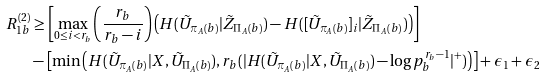<formula> <loc_0><loc_0><loc_500><loc_500>R _ { 1 b } ^ { ( 2 ) } & \geq \left [ \max _ { 0 \leq i < r _ { b } } \left ( \frac { r _ { b } } { r _ { b } - i } \right ) \left ( H ( \tilde { U } _ { \pi _ { A } ( b ) } | \tilde { Z } _ { \Pi _ { A } ( b ) } ) - H ( [ \tilde { U } _ { \pi _ { A } ( b ) } ] _ { i } | \tilde { Z } _ { \Pi _ { A } ( b ) } ) \right ) \right ] \\ & - \left [ \min \left ( H ( \tilde { U } _ { \pi _ { A } ( b ) } | X , \tilde { U } _ { \Pi _ { A } ( b ) } ) , r _ { b } ( | H ( \tilde { U } _ { \pi _ { A } ( b ) } | X , \tilde { U } _ { \Pi _ { A } ( b ) } ) - \log p _ { b } ^ { r _ { b } - 1 } | ^ { + } ) \right ) \right ] + \epsilon _ { 1 } + \epsilon _ { 2 }</formula> 